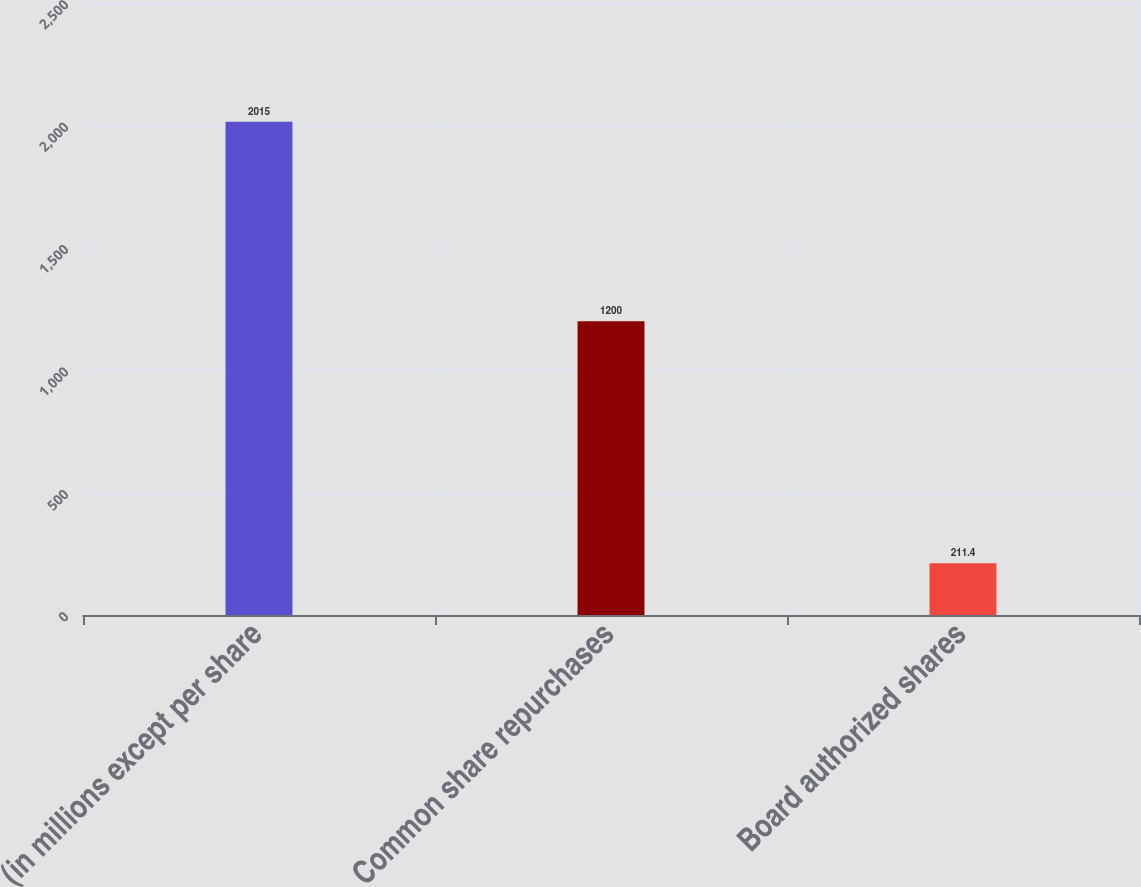Convert chart. <chart><loc_0><loc_0><loc_500><loc_500><bar_chart><fcel>(in millions except per share<fcel>Common share repurchases<fcel>Board authorized shares<nl><fcel>2015<fcel>1200<fcel>211.4<nl></chart> 